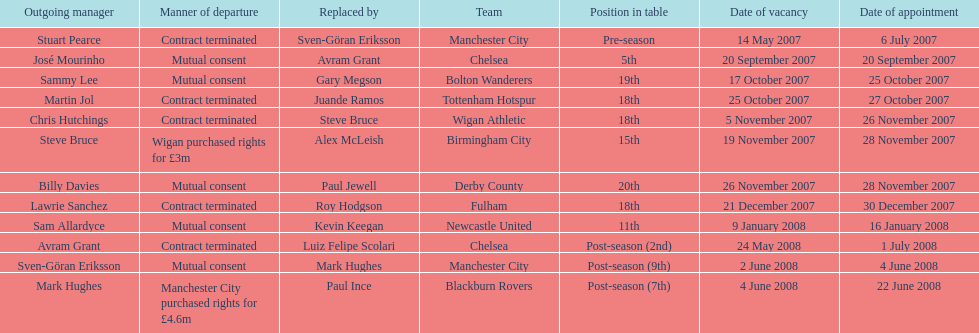Which outgoing manager was appointed the last? Mark Hughes. 